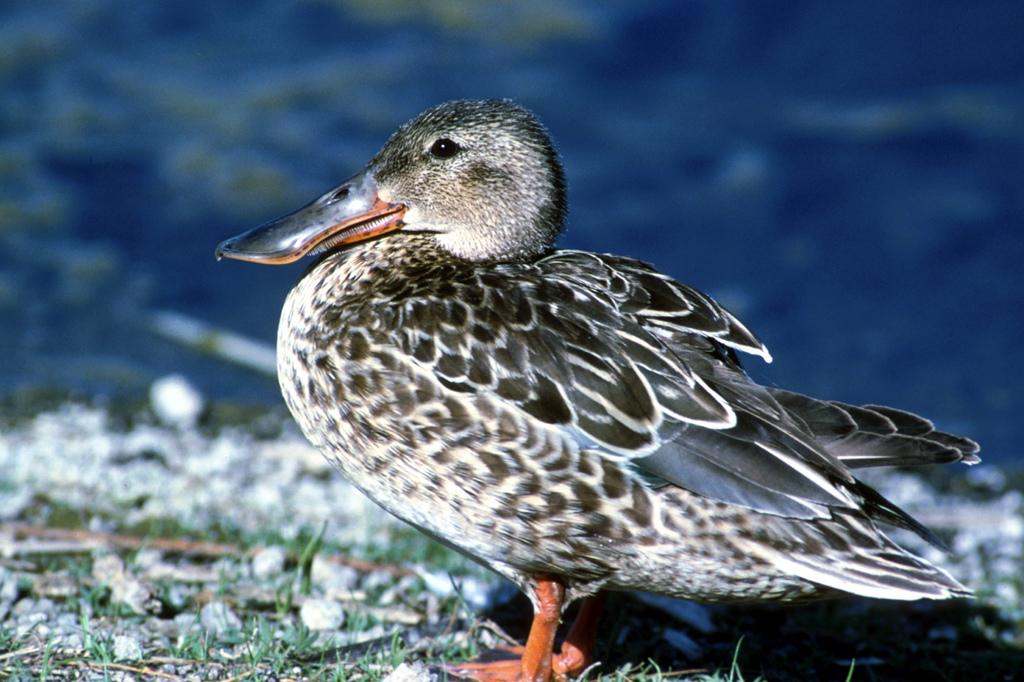What animal can be seen in the picture? There is a duck in the picture. What type of terrain is visible in the picture? There is grass on the ground in the picture. How would you describe the background of the image? The background of the image is blurry. What type of weather can be seen in the image? The provided facts do not mention any weather conditions, so it cannot be determined from the image. Can you see a head in the image? There is no head mentioned or visible in the image; it only features a duck and grass. 